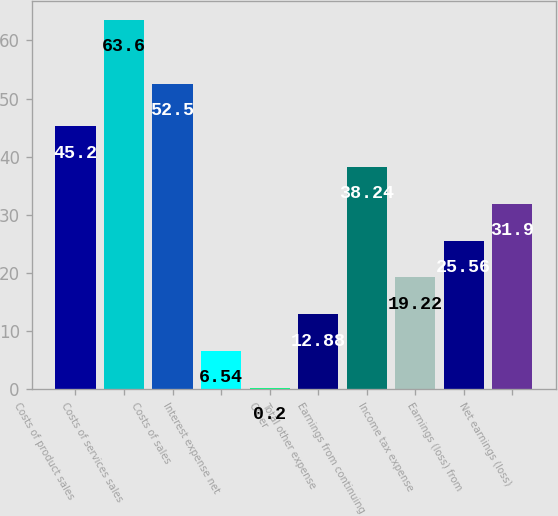Convert chart. <chart><loc_0><loc_0><loc_500><loc_500><bar_chart><fcel>Costs of product sales<fcel>Costs of services sales<fcel>Costs of sales<fcel>Interest expense net<fcel>Other<fcel>Total other expense<fcel>Earnings from continuing<fcel>Income tax expense<fcel>Earnings (loss) from<fcel>Net earnings (loss)<nl><fcel>45.2<fcel>63.6<fcel>52.5<fcel>6.54<fcel>0.2<fcel>12.88<fcel>38.24<fcel>19.22<fcel>25.56<fcel>31.9<nl></chart> 